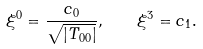Convert formula to latex. <formula><loc_0><loc_0><loc_500><loc_500>\xi ^ { 0 } = \frac { c _ { 0 } } { \sqrt { | T _ { 0 0 } | } } , \quad \xi ^ { 3 } = c _ { 1 } .</formula> 